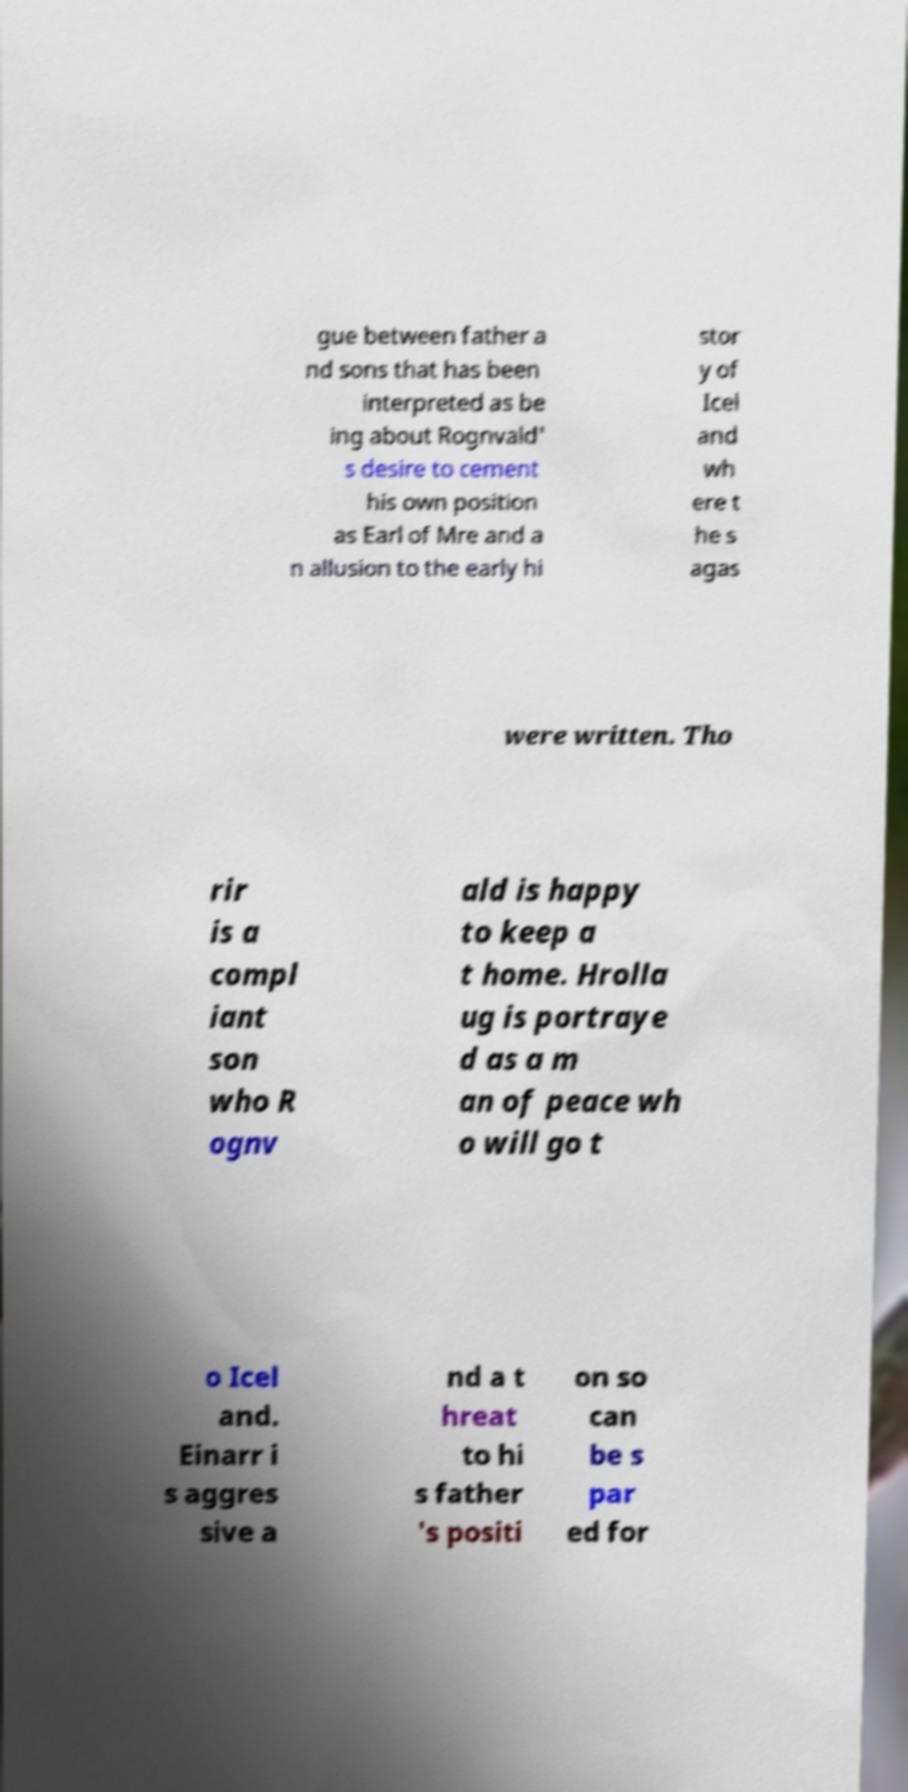Please read and relay the text visible in this image. What does it say? gue between father a nd sons that has been interpreted as be ing about Rognvald' s desire to cement his own position as Earl of Mre and a n allusion to the early hi stor y of Icel and wh ere t he s agas were written. Tho rir is a compl iant son who R ognv ald is happy to keep a t home. Hrolla ug is portraye d as a m an of peace wh o will go t o Icel and. Einarr i s aggres sive a nd a t hreat to hi s father 's positi on so can be s par ed for 